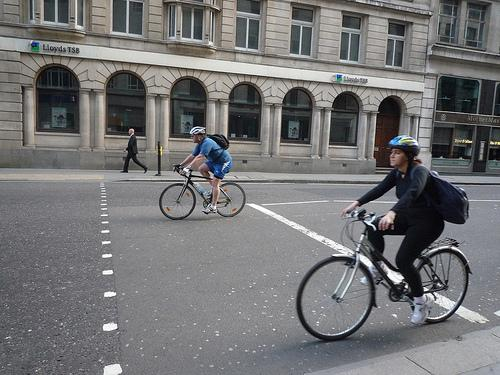Describe one architectural feature of the building along the sidewalk. The building has a large arched window along the sidewalk. Mention one accessory present on the bikes, and specify its color. There are two orange bike reflectors on the bikes. What is a notable accessory both bike riders are carrying, and what color is one of them? Both bike riders are carrying backpacks, and one of them is blue. Explain the appearance of the helmet worn by the lady riding the bike. The lady is wearing a green and blue bike helmet. Identify the primary activity that two people are engaging in on the street. Two people are riding their bikes on the street. What is the man walking on the sidewalk wearing, and is there any specific detail about his appearance? The man walking on the sidewalk is wearing a black suit, and he is bald. Choose an element of the image that could be used for a product advertisement, and briefly explain why. The bicycle helmets could be used for a product advertisement, as they represent safety and style for bike riders. Which task involves identifying the location of specific items or characters within an image? Referential expression grounding task. What particular markings can be seen on the pavement in the image? There are white markings on the pavement. In a multi-choice VQA task, what are the key details about the man riding a bike in the image? The man is riding a bike, wearing a blue shirt and shorts, and carrying a backpack. 